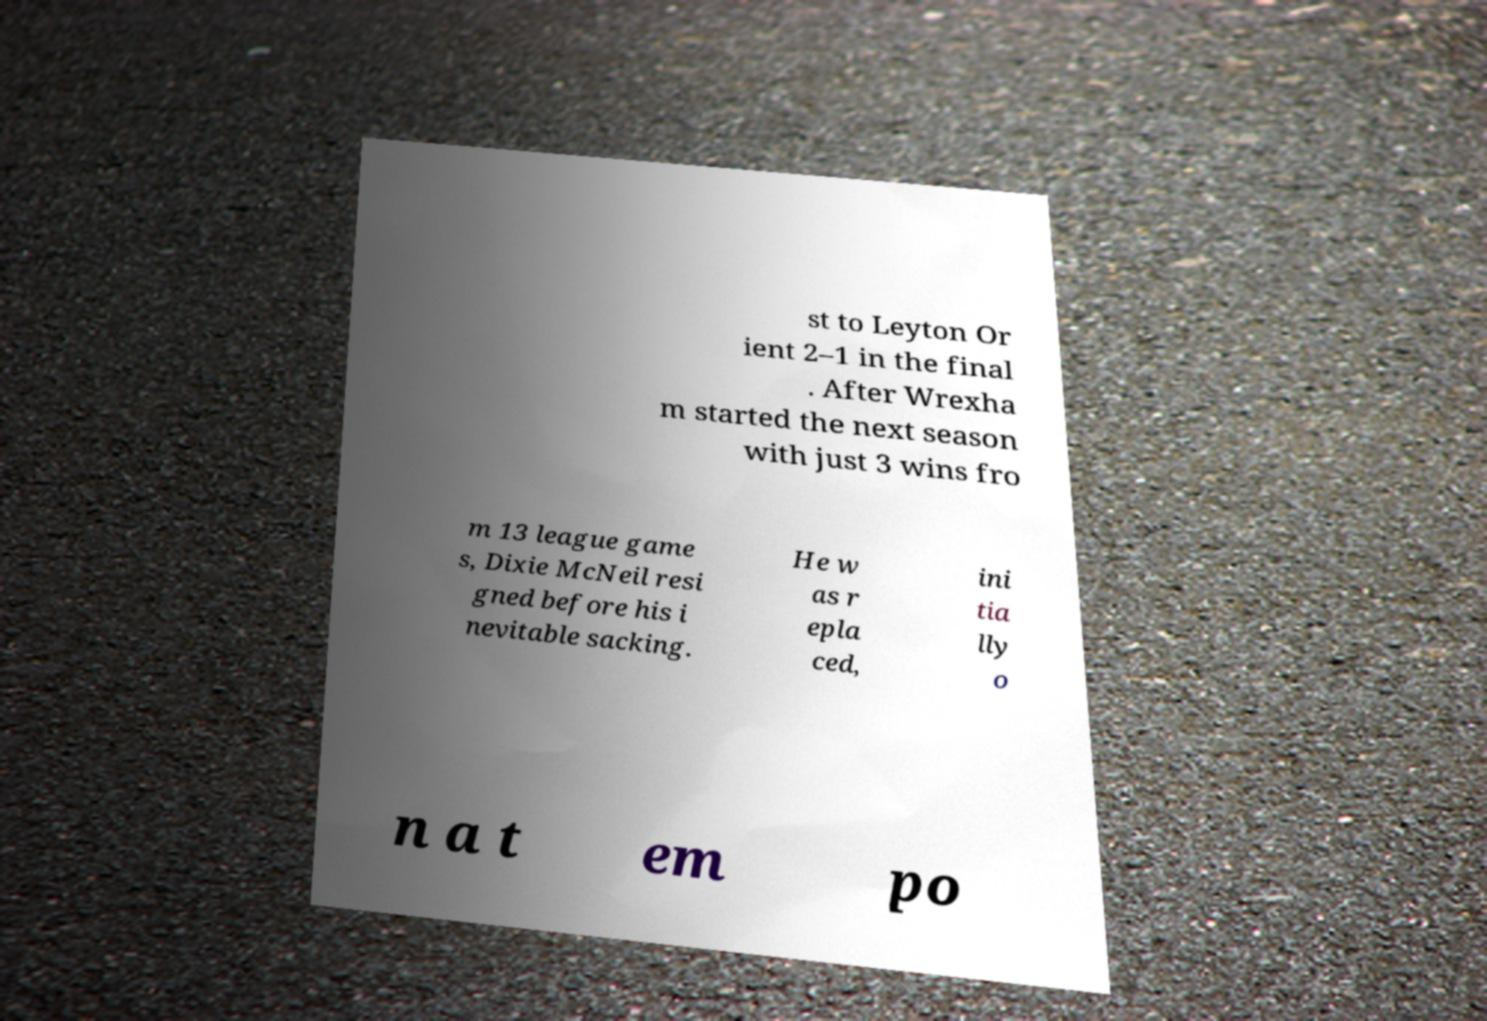What messages or text are displayed in this image? I need them in a readable, typed format. st to Leyton Or ient 2–1 in the final . After Wrexha m started the next season with just 3 wins fro m 13 league game s, Dixie McNeil resi gned before his i nevitable sacking. He w as r epla ced, ini tia lly o n a t em po 